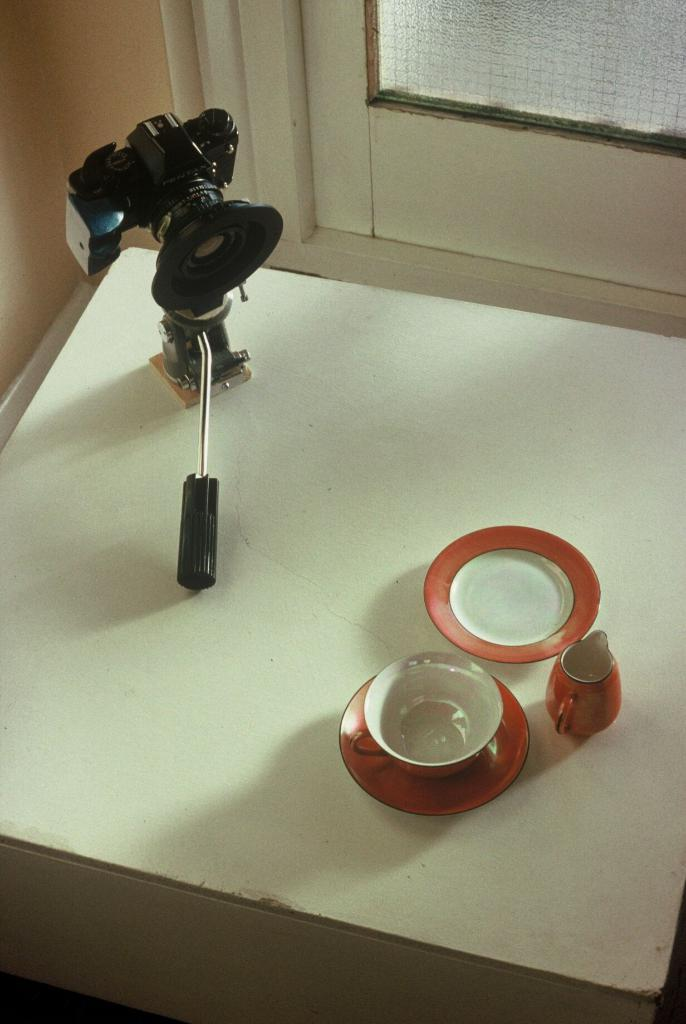What is the main object in the image? There is a camera on a stand in the image. What other objects can be seen in the image? There are saucers, a cup, and a small jug in the image. Is there any source of natural light visible in the image? Yes, there is a small window in the image. How many bears can be seen in the image? There are no bears present in the image. What type of toothbrush is visible in the image? There is no toothbrush present in the image. 